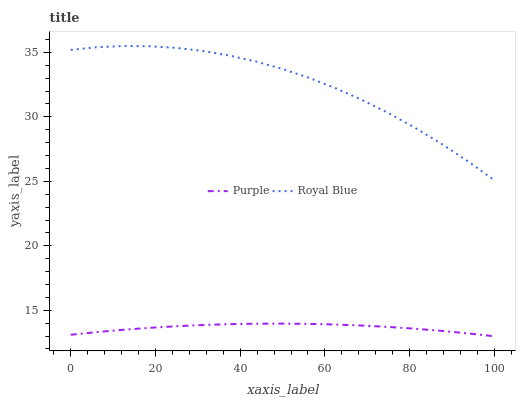Does Royal Blue have the minimum area under the curve?
Answer yes or no. No. Is Royal Blue the smoothest?
Answer yes or no. No. Does Royal Blue have the lowest value?
Answer yes or no. No. Is Purple less than Royal Blue?
Answer yes or no. Yes. Is Royal Blue greater than Purple?
Answer yes or no. Yes. Does Purple intersect Royal Blue?
Answer yes or no. No. 